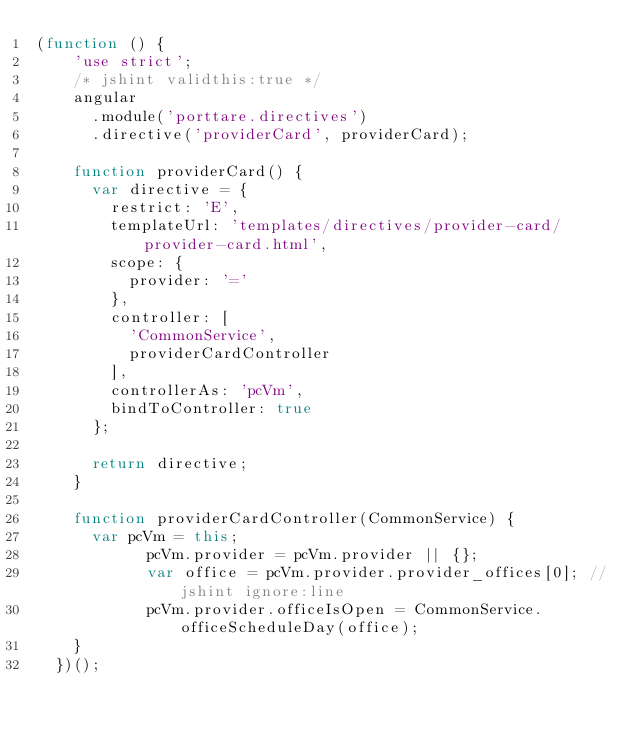<code> <loc_0><loc_0><loc_500><loc_500><_JavaScript_>(function () {
    'use strict';
    /* jshint validthis:true */
    angular
      .module('porttare.directives')
      .directive('providerCard', providerCard);

    function providerCard() {
      var directive = {
        restrict: 'E',
        templateUrl: 'templates/directives/provider-card/provider-card.html',
        scope: {
          provider: '='
        },
        controller: [
          'CommonService',
          providerCardController
        ],
        controllerAs: 'pcVm',
        bindToController: true
      };

      return directive;
    }

    function providerCardController(CommonService) {
      var pcVm = this;
			pcVm.provider = pcVm.provider || {};
			var office = pcVm.provider.provider_offices[0]; //jshint ignore:line
			pcVm.provider.officeIsOpen = CommonService.officeScheduleDay(office);
    }
  })();
</code> 